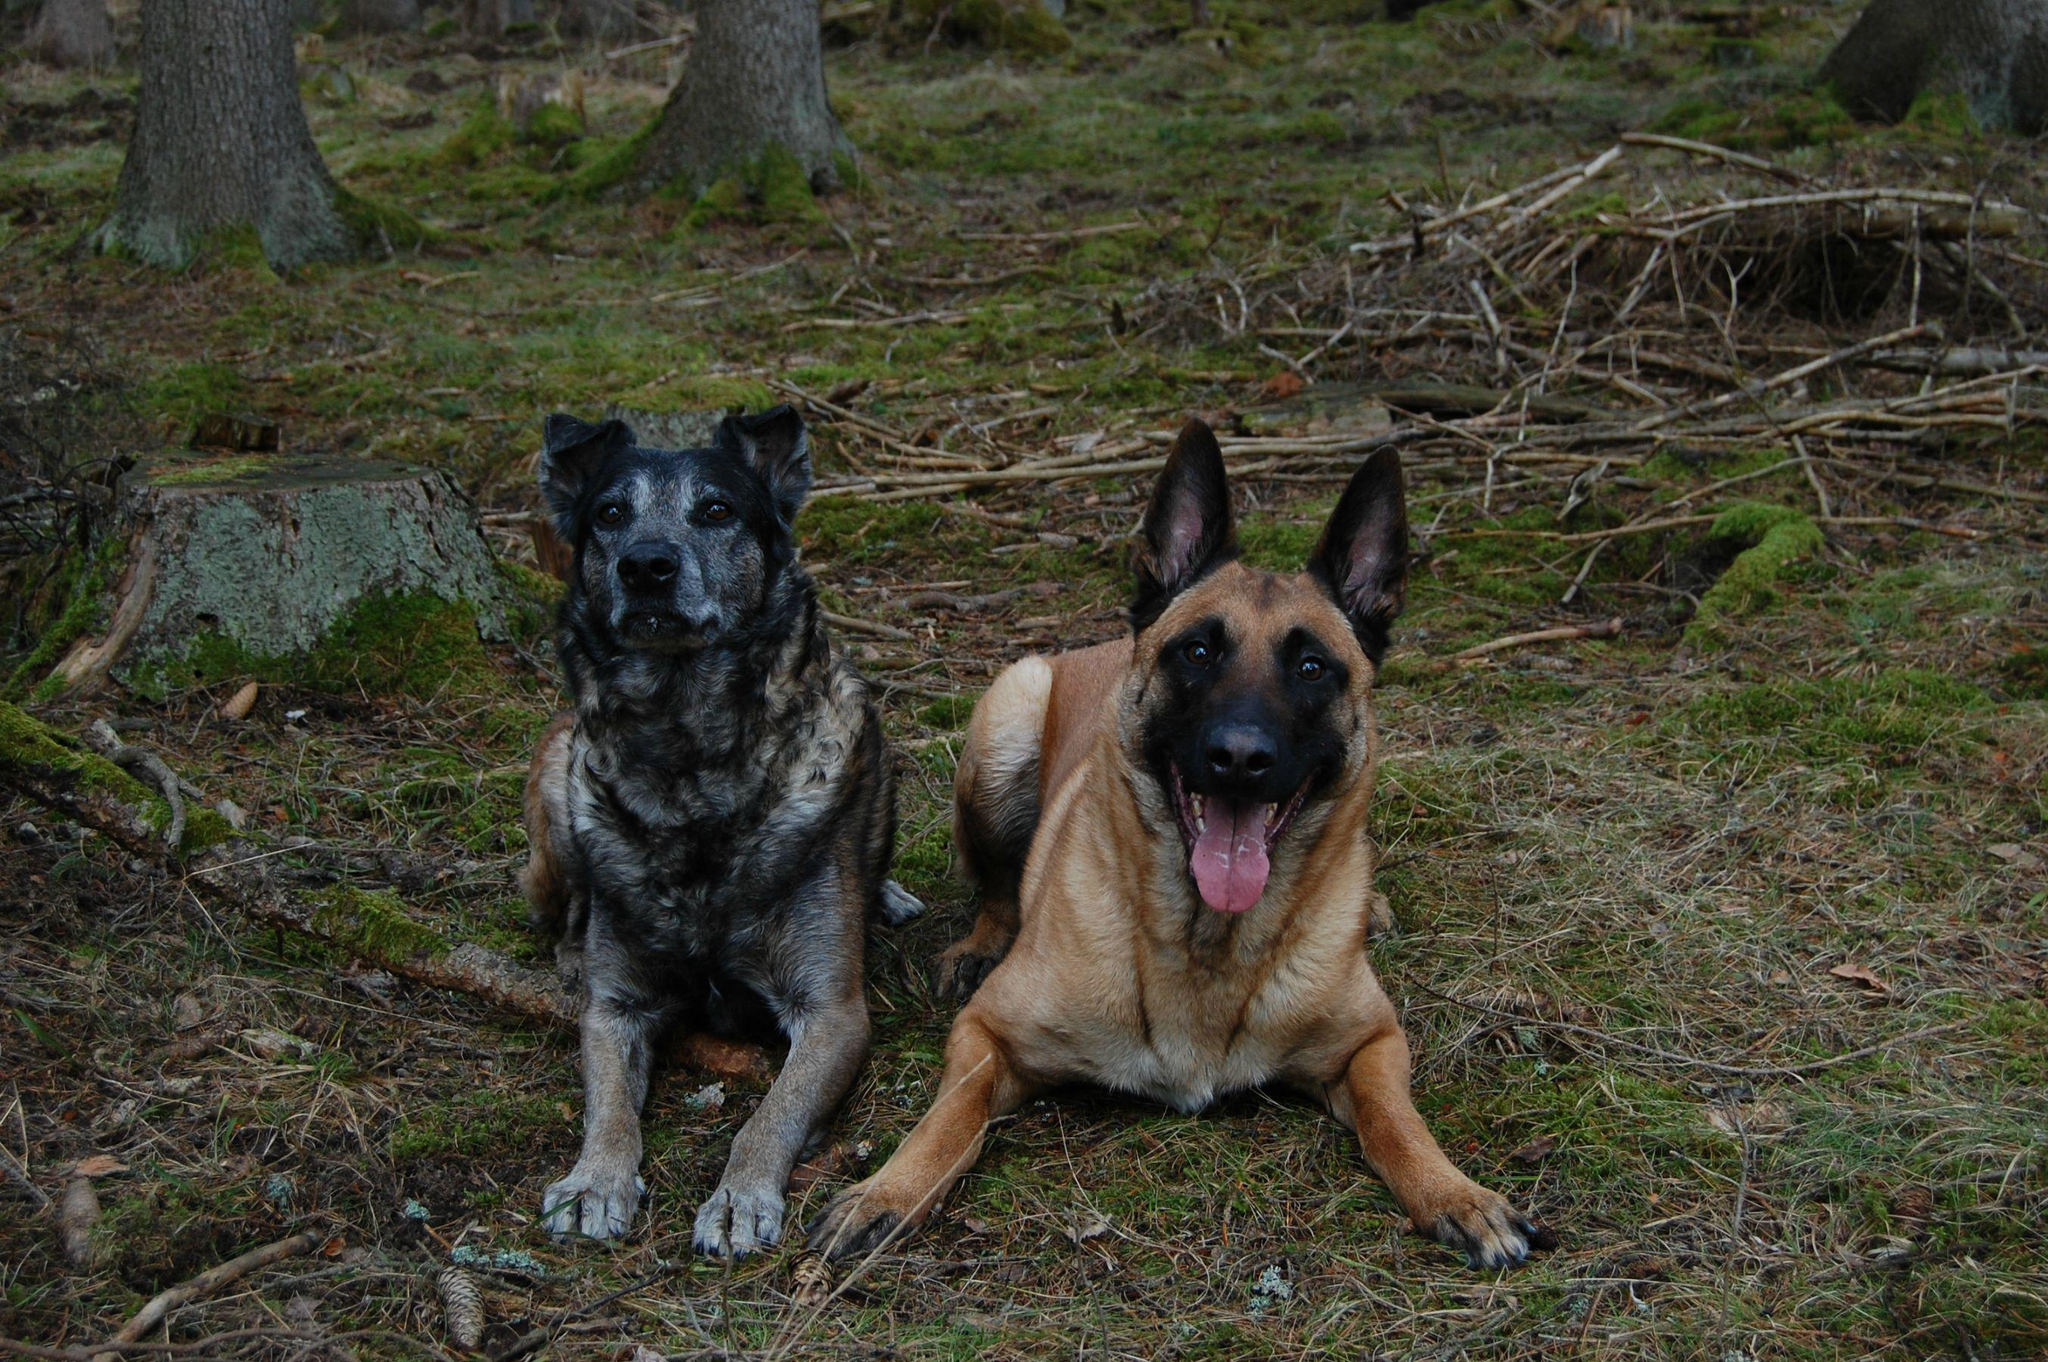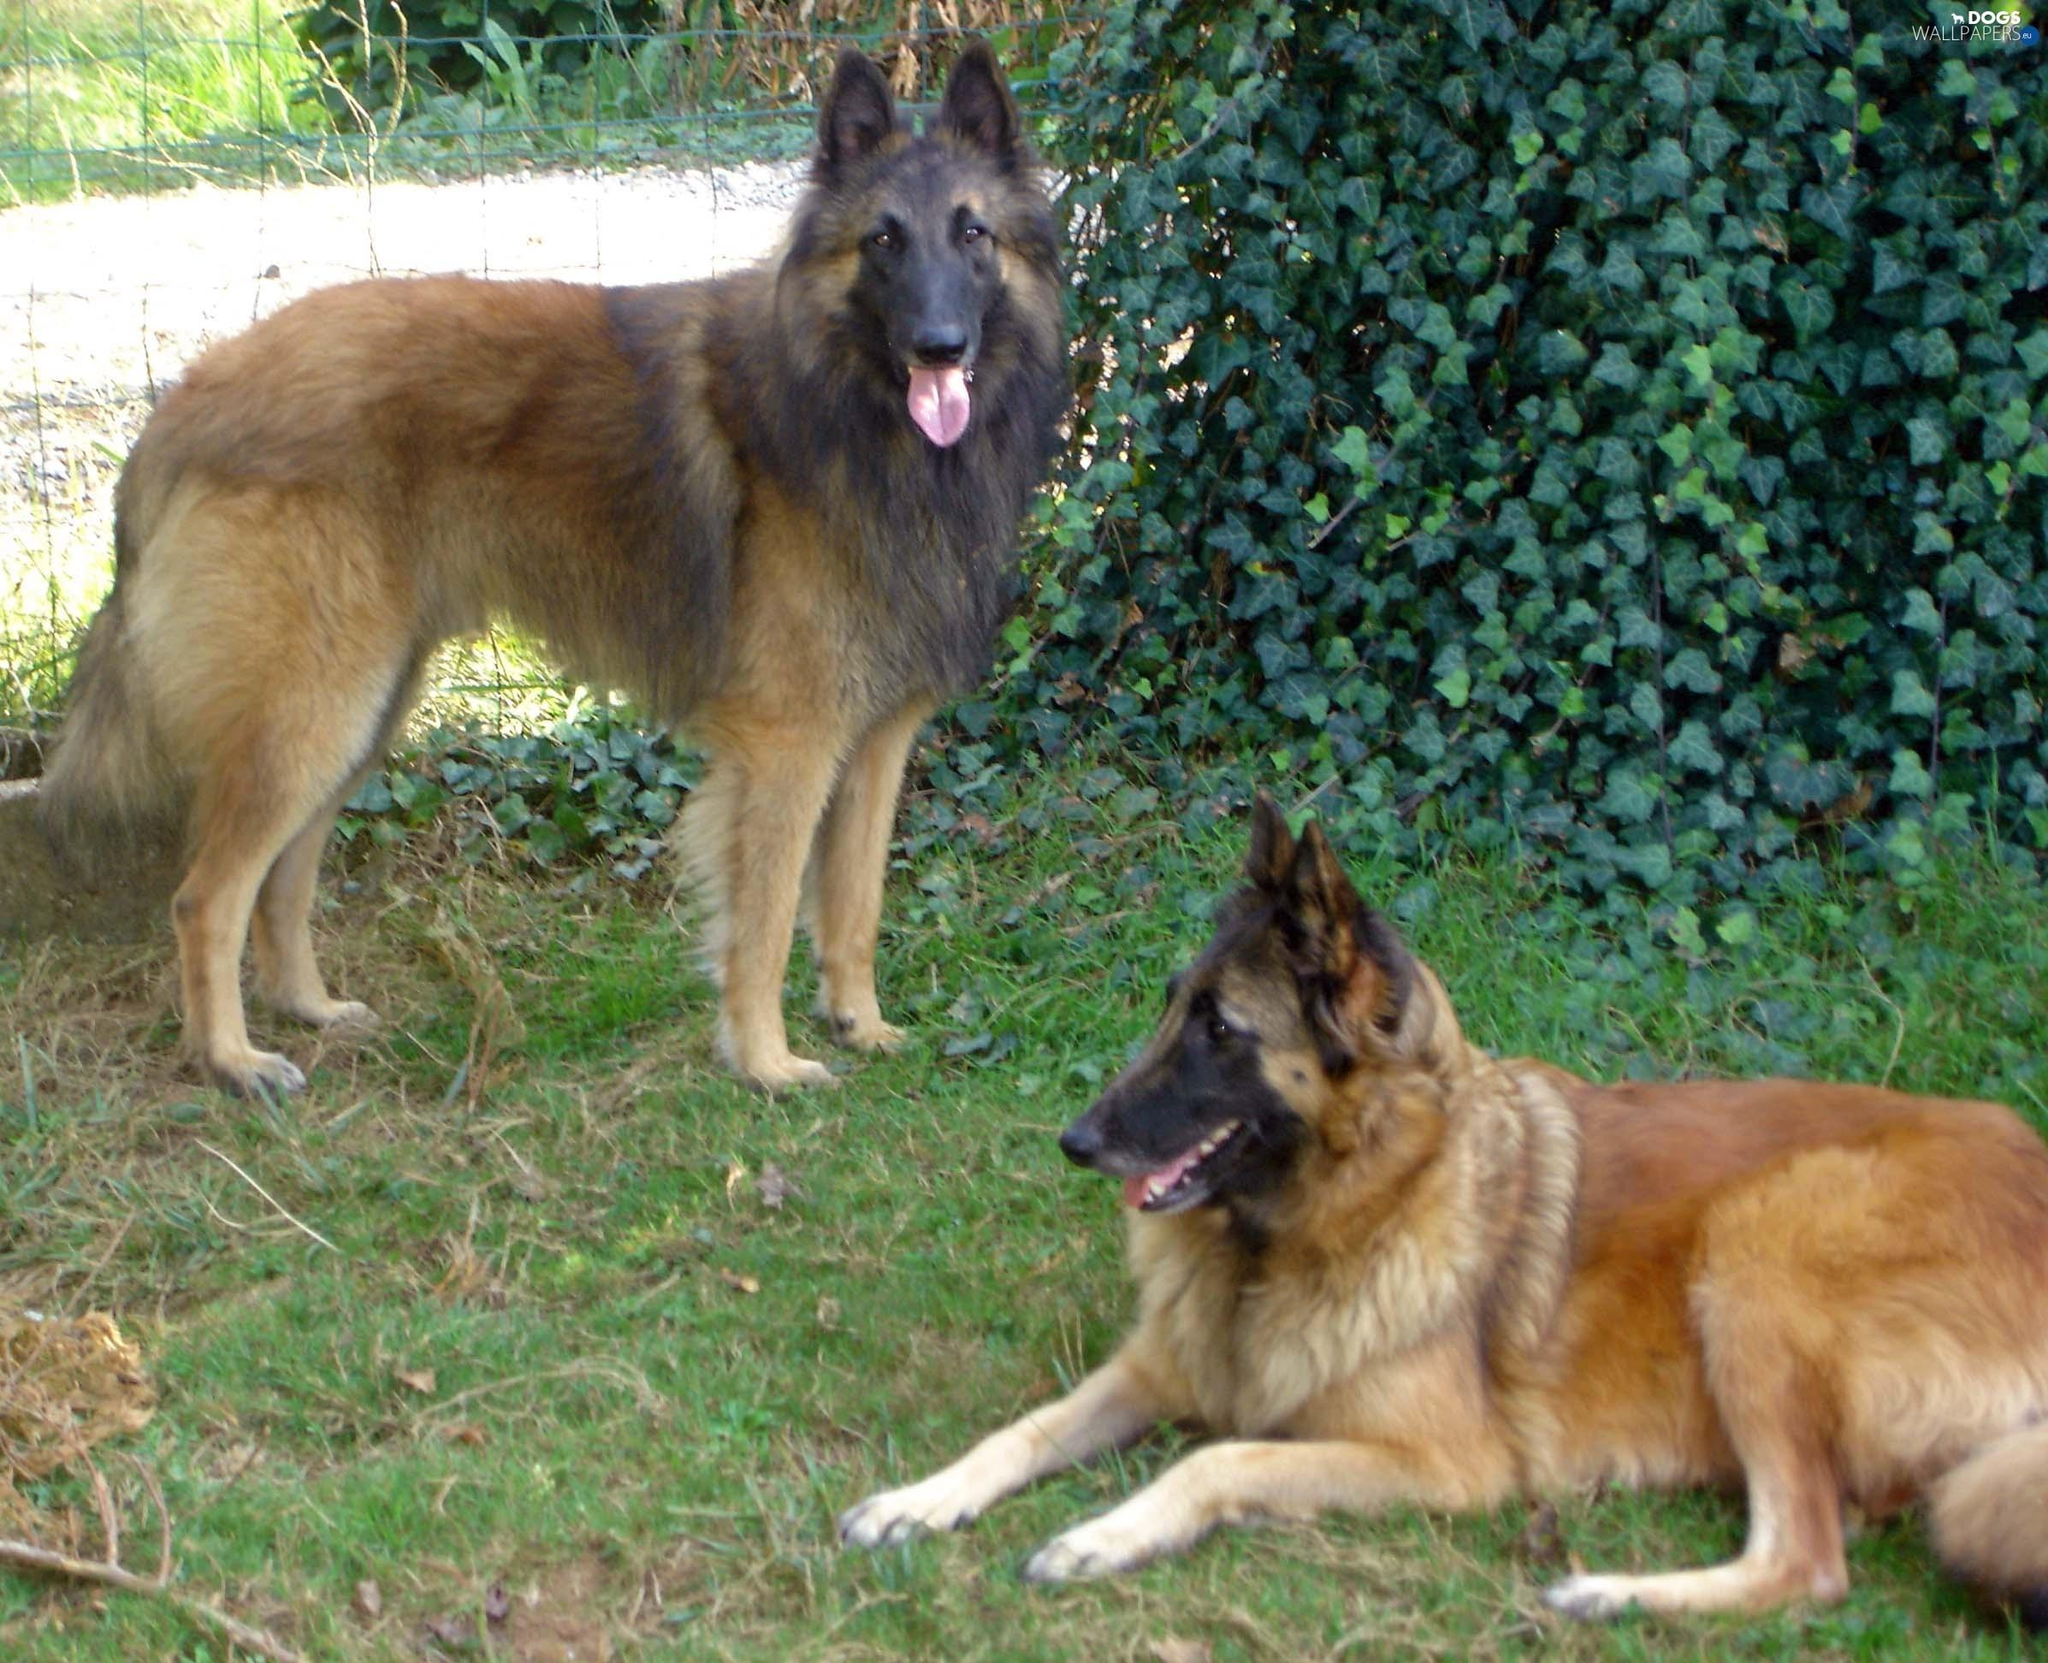The first image is the image on the left, the second image is the image on the right. Evaluate the accuracy of this statement regarding the images: "At least two dogs are lying down on the ground.". Is it true? Answer yes or no. Yes. The first image is the image on the left, the second image is the image on the right. For the images displayed, is the sentence "There are 2 or more German Shepard's laying down on grass." factually correct? Answer yes or no. Yes. 